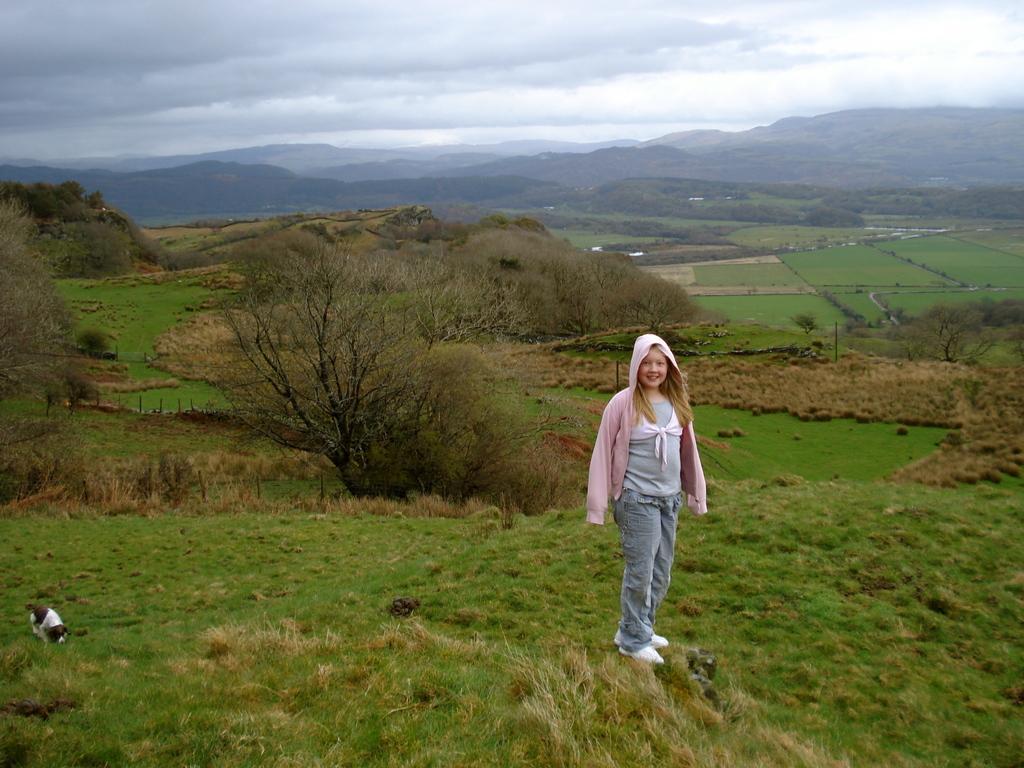Can you describe this image briefly? As we can see in the image there is grass, trees, hills, dog and a girl standing. At the top there is sky and clouds. 